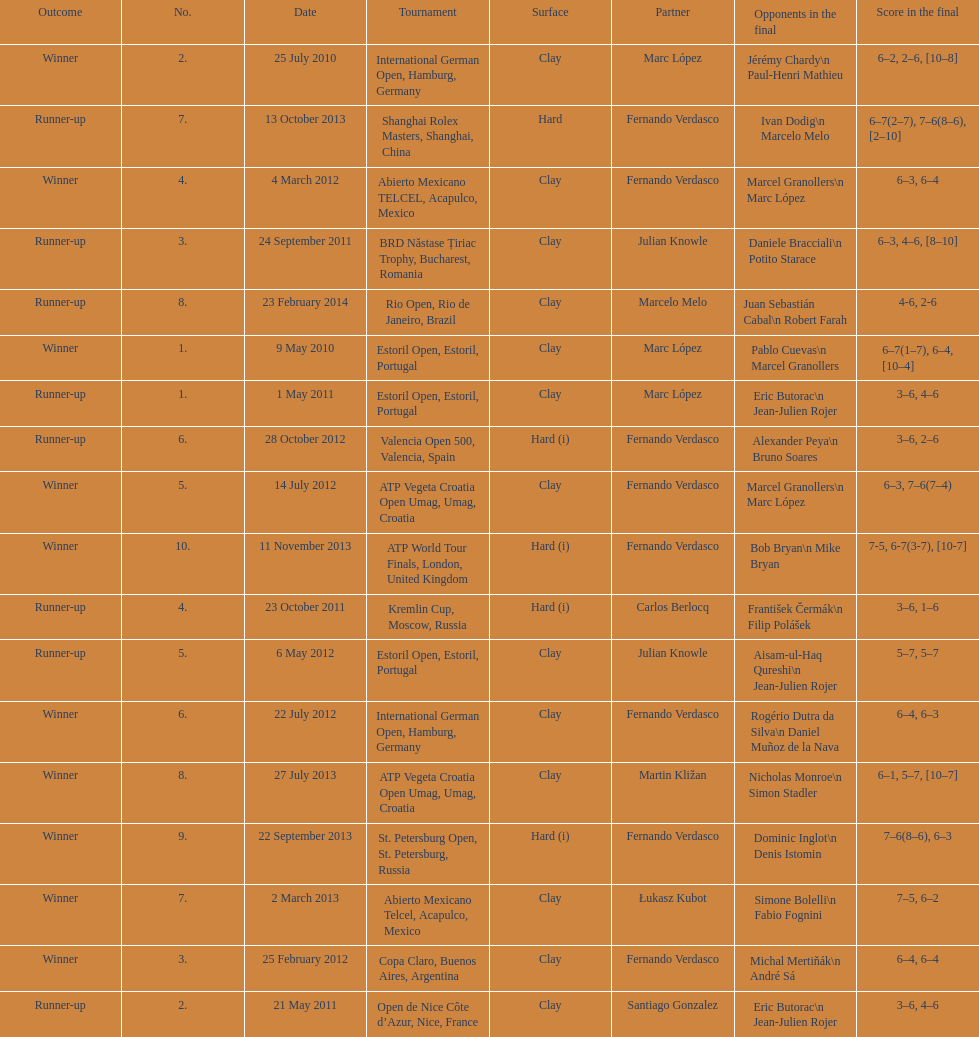Who won both the st.petersburg open and the atp world tour finals? Fernando Verdasco. 